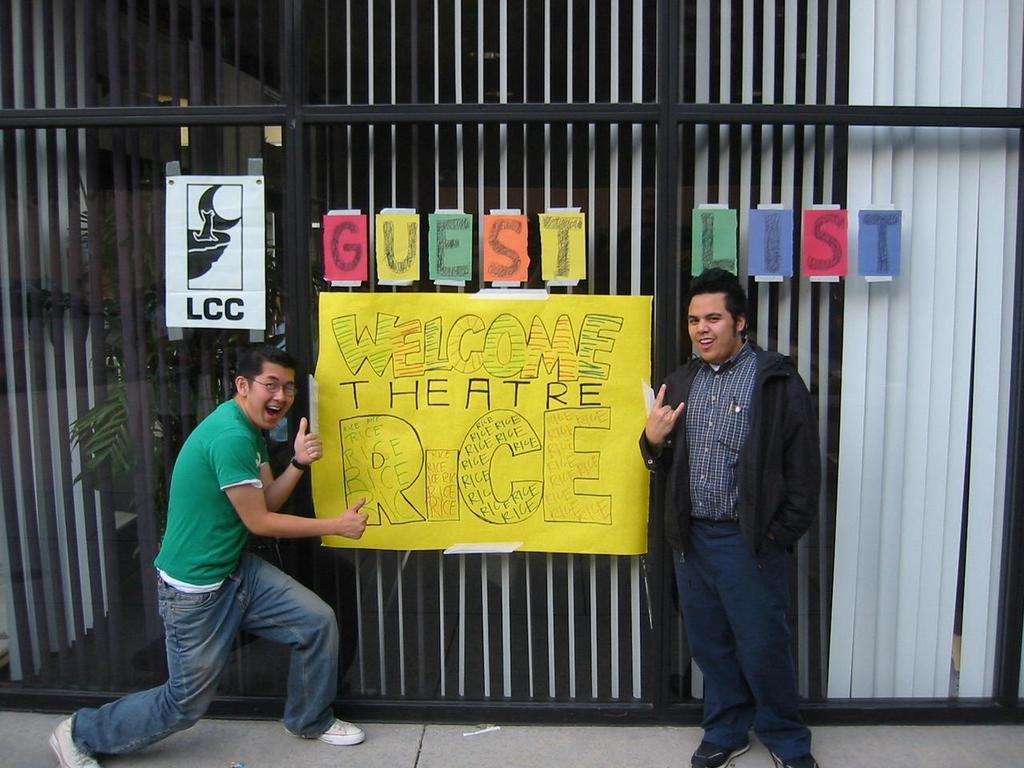How many people are in the image? There are two men standing in the image. What can be seen in the background of the image? There is glass in the background of the image. What is on the glass in the image? There are papers pasted on the glass. What can be seen through the glass in the image? Window blinds and a plant are visible through the glass. What type of roof can be seen in the image? There is no roof visible in the image; it primarily features two men and a glass background with papers and a plant visible through it. 